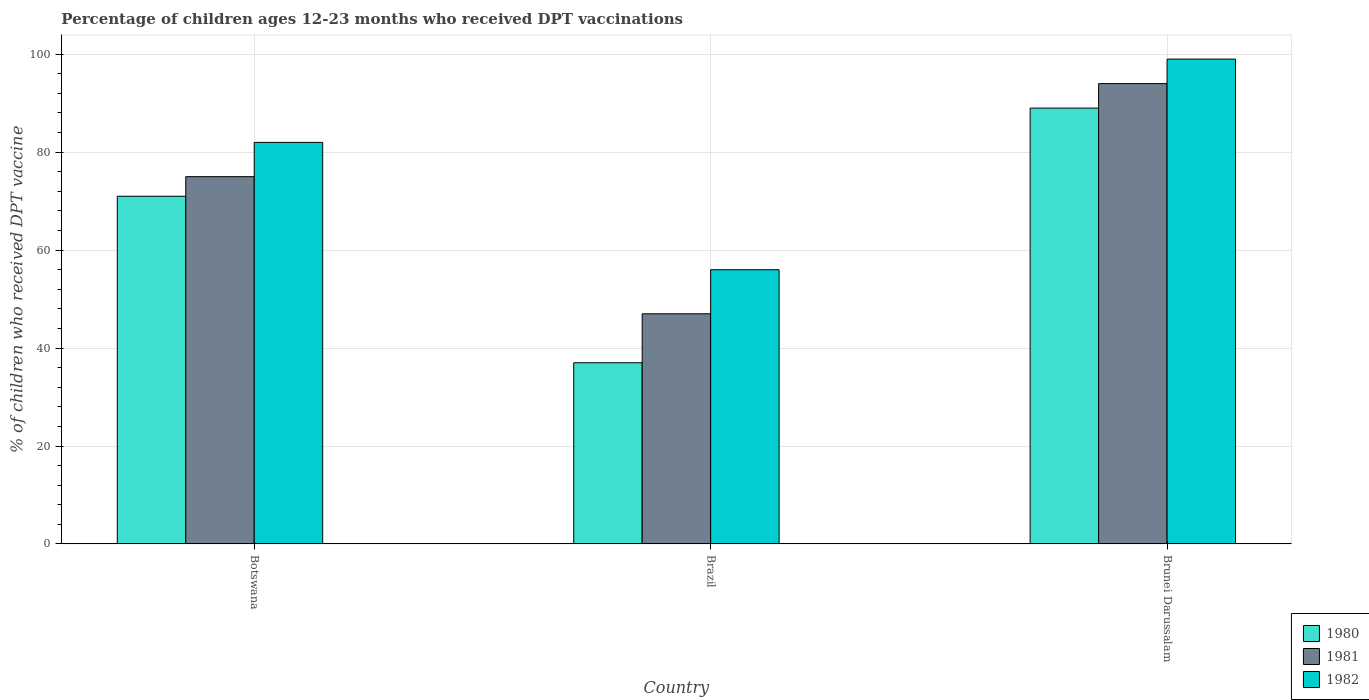Are the number of bars per tick equal to the number of legend labels?
Provide a short and direct response. Yes. How many bars are there on the 1st tick from the left?
Provide a succinct answer. 3. How many bars are there on the 2nd tick from the right?
Your answer should be very brief. 3. What is the label of the 2nd group of bars from the left?
Offer a very short reply. Brazil. What is the percentage of children who received DPT vaccination in 1981 in Brunei Darussalam?
Offer a terse response. 94. Across all countries, what is the maximum percentage of children who received DPT vaccination in 1982?
Provide a succinct answer. 99. Across all countries, what is the minimum percentage of children who received DPT vaccination in 1982?
Provide a succinct answer. 56. In which country was the percentage of children who received DPT vaccination in 1980 maximum?
Your answer should be very brief. Brunei Darussalam. In which country was the percentage of children who received DPT vaccination in 1980 minimum?
Give a very brief answer. Brazil. What is the total percentage of children who received DPT vaccination in 1980 in the graph?
Ensure brevity in your answer.  197. What is the difference between the percentage of children who received DPT vaccination in 1980 in Brazil and that in Brunei Darussalam?
Make the answer very short. -52. What is the average percentage of children who received DPT vaccination in 1980 per country?
Make the answer very short. 65.67. What is the difference between the percentage of children who received DPT vaccination of/in 1981 and percentage of children who received DPT vaccination of/in 1982 in Brunei Darussalam?
Provide a succinct answer. -5. In how many countries, is the percentage of children who received DPT vaccination in 1982 greater than 60 %?
Your answer should be very brief. 2. What is the ratio of the percentage of children who received DPT vaccination in 1980 in Botswana to that in Brazil?
Offer a terse response. 1.92. Is the percentage of children who received DPT vaccination in 1980 in Botswana less than that in Brunei Darussalam?
Offer a terse response. Yes. What is the difference between the highest and the lowest percentage of children who received DPT vaccination in 1980?
Keep it short and to the point. 52. In how many countries, is the percentage of children who received DPT vaccination in 1980 greater than the average percentage of children who received DPT vaccination in 1980 taken over all countries?
Keep it short and to the point. 2. Is the sum of the percentage of children who received DPT vaccination in 1981 in Brazil and Brunei Darussalam greater than the maximum percentage of children who received DPT vaccination in 1980 across all countries?
Your answer should be very brief. Yes. Is it the case that in every country, the sum of the percentage of children who received DPT vaccination in 1981 and percentage of children who received DPT vaccination in 1980 is greater than the percentage of children who received DPT vaccination in 1982?
Offer a terse response. Yes. How many bars are there?
Make the answer very short. 9. What is the difference between two consecutive major ticks on the Y-axis?
Ensure brevity in your answer.  20. Are the values on the major ticks of Y-axis written in scientific E-notation?
Keep it short and to the point. No. Does the graph contain any zero values?
Offer a very short reply. No. Does the graph contain grids?
Offer a terse response. Yes. Where does the legend appear in the graph?
Provide a succinct answer. Bottom right. What is the title of the graph?
Offer a terse response. Percentage of children ages 12-23 months who received DPT vaccinations. What is the label or title of the Y-axis?
Your answer should be very brief. % of children who received DPT vaccine. What is the % of children who received DPT vaccine of 1980 in Botswana?
Ensure brevity in your answer.  71. What is the % of children who received DPT vaccine of 1981 in Botswana?
Provide a succinct answer. 75. What is the % of children who received DPT vaccine in 1980 in Brazil?
Your answer should be very brief. 37. What is the % of children who received DPT vaccine in 1982 in Brazil?
Keep it short and to the point. 56. What is the % of children who received DPT vaccine in 1980 in Brunei Darussalam?
Your answer should be very brief. 89. What is the % of children who received DPT vaccine in 1981 in Brunei Darussalam?
Offer a very short reply. 94. Across all countries, what is the maximum % of children who received DPT vaccine of 1980?
Your response must be concise. 89. Across all countries, what is the maximum % of children who received DPT vaccine of 1981?
Provide a short and direct response. 94. Across all countries, what is the maximum % of children who received DPT vaccine in 1982?
Your answer should be compact. 99. What is the total % of children who received DPT vaccine of 1980 in the graph?
Offer a very short reply. 197. What is the total % of children who received DPT vaccine in 1981 in the graph?
Make the answer very short. 216. What is the total % of children who received DPT vaccine of 1982 in the graph?
Offer a terse response. 237. What is the difference between the % of children who received DPT vaccine in 1981 in Botswana and that in Brazil?
Provide a short and direct response. 28. What is the difference between the % of children who received DPT vaccine in 1982 in Botswana and that in Brunei Darussalam?
Your response must be concise. -17. What is the difference between the % of children who received DPT vaccine of 1980 in Brazil and that in Brunei Darussalam?
Make the answer very short. -52. What is the difference between the % of children who received DPT vaccine of 1981 in Brazil and that in Brunei Darussalam?
Provide a short and direct response. -47. What is the difference between the % of children who received DPT vaccine of 1982 in Brazil and that in Brunei Darussalam?
Ensure brevity in your answer.  -43. What is the difference between the % of children who received DPT vaccine of 1980 in Botswana and the % of children who received DPT vaccine of 1981 in Brazil?
Your answer should be very brief. 24. What is the difference between the % of children who received DPT vaccine in 1980 in Botswana and the % of children who received DPT vaccine in 1982 in Brunei Darussalam?
Keep it short and to the point. -28. What is the difference between the % of children who received DPT vaccine of 1980 in Brazil and the % of children who received DPT vaccine of 1981 in Brunei Darussalam?
Your answer should be very brief. -57. What is the difference between the % of children who received DPT vaccine in 1980 in Brazil and the % of children who received DPT vaccine in 1982 in Brunei Darussalam?
Your response must be concise. -62. What is the difference between the % of children who received DPT vaccine in 1981 in Brazil and the % of children who received DPT vaccine in 1982 in Brunei Darussalam?
Your answer should be compact. -52. What is the average % of children who received DPT vaccine in 1980 per country?
Your response must be concise. 65.67. What is the average % of children who received DPT vaccine in 1981 per country?
Your response must be concise. 72. What is the average % of children who received DPT vaccine in 1982 per country?
Provide a succinct answer. 79. What is the difference between the % of children who received DPT vaccine of 1980 and % of children who received DPT vaccine of 1982 in Botswana?
Provide a succinct answer. -11. What is the difference between the % of children who received DPT vaccine in 1981 and % of children who received DPT vaccine in 1982 in Botswana?
Ensure brevity in your answer.  -7. What is the difference between the % of children who received DPT vaccine of 1981 and % of children who received DPT vaccine of 1982 in Brazil?
Keep it short and to the point. -9. What is the ratio of the % of children who received DPT vaccine of 1980 in Botswana to that in Brazil?
Keep it short and to the point. 1.92. What is the ratio of the % of children who received DPT vaccine of 1981 in Botswana to that in Brazil?
Ensure brevity in your answer.  1.6. What is the ratio of the % of children who received DPT vaccine in 1982 in Botswana to that in Brazil?
Your answer should be compact. 1.46. What is the ratio of the % of children who received DPT vaccine of 1980 in Botswana to that in Brunei Darussalam?
Offer a terse response. 0.8. What is the ratio of the % of children who received DPT vaccine in 1981 in Botswana to that in Brunei Darussalam?
Your response must be concise. 0.8. What is the ratio of the % of children who received DPT vaccine in 1982 in Botswana to that in Brunei Darussalam?
Make the answer very short. 0.83. What is the ratio of the % of children who received DPT vaccine of 1980 in Brazil to that in Brunei Darussalam?
Your answer should be very brief. 0.42. What is the ratio of the % of children who received DPT vaccine of 1981 in Brazil to that in Brunei Darussalam?
Your answer should be very brief. 0.5. What is the ratio of the % of children who received DPT vaccine of 1982 in Brazil to that in Brunei Darussalam?
Keep it short and to the point. 0.57. What is the difference between the highest and the second highest % of children who received DPT vaccine of 1980?
Your response must be concise. 18. What is the difference between the highest and the lowest % of children who received DPT vaccine in 1980?
Keep it short and to the point. 52. What is the difference between the highest and the lowest % of children who received DPT vaccine in 1981?
Give a very brief answer. 47. 